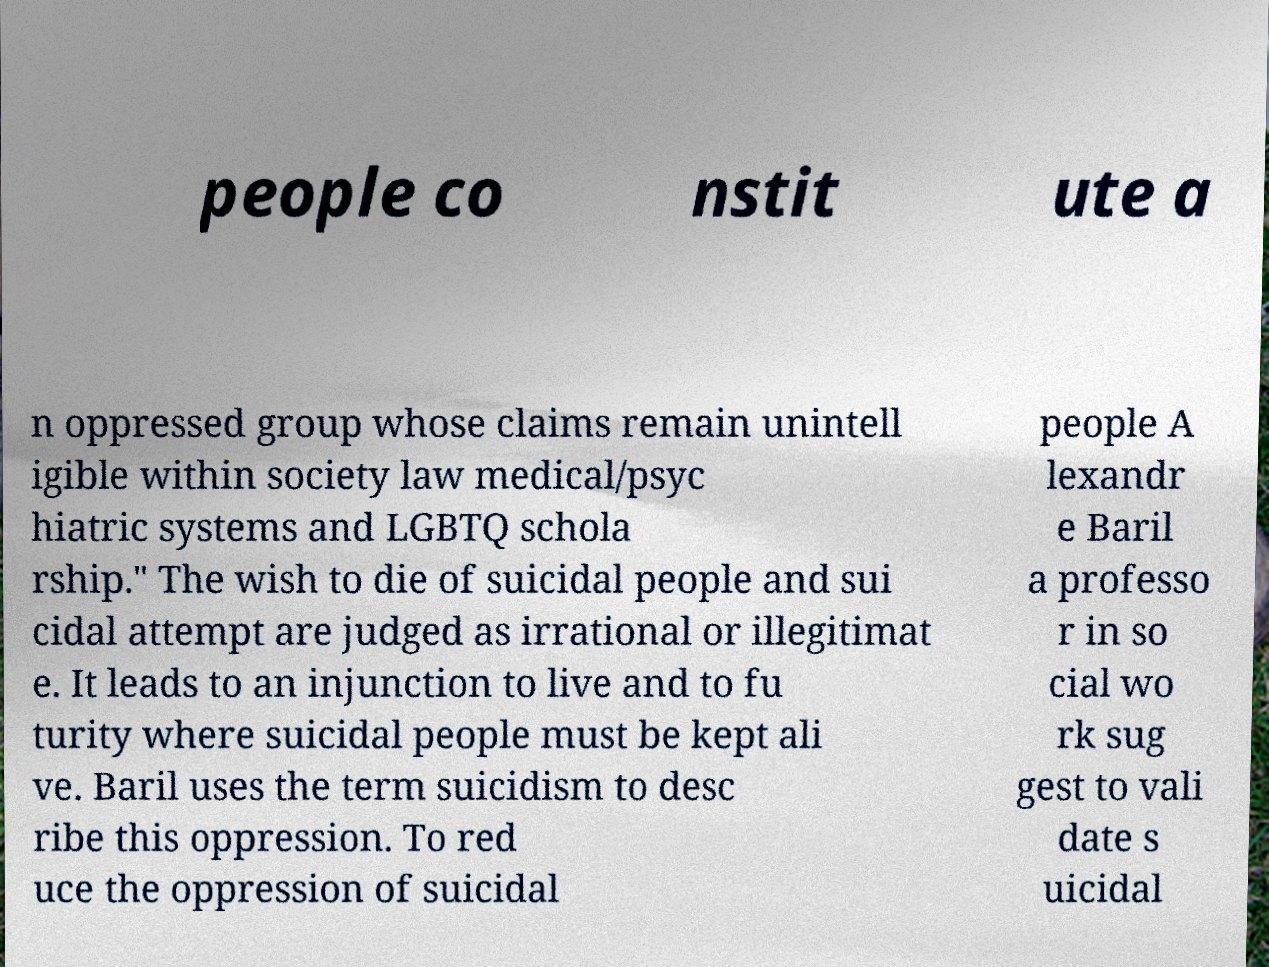There's text embedded in this image that I need extracted. Can you transcribe it verbatim? people co nstit ute a n oppressed group whose claims remain unintell igible within society law medical/psyc hiatric systems and LGBTQ schola rship." The wish to die of suicidal people and sui cidal attempt are judged as irrational or illegitimat e. It leads to an injunction to live and to fu turity where suicidal people must be kept ali ve. Baril uses the term suicidism to desc ribe this oppression. To red uce the oppression of suicidal people A lexandr e Baril a professo r in so cial wo rk sug gest to vali date s uicidal 